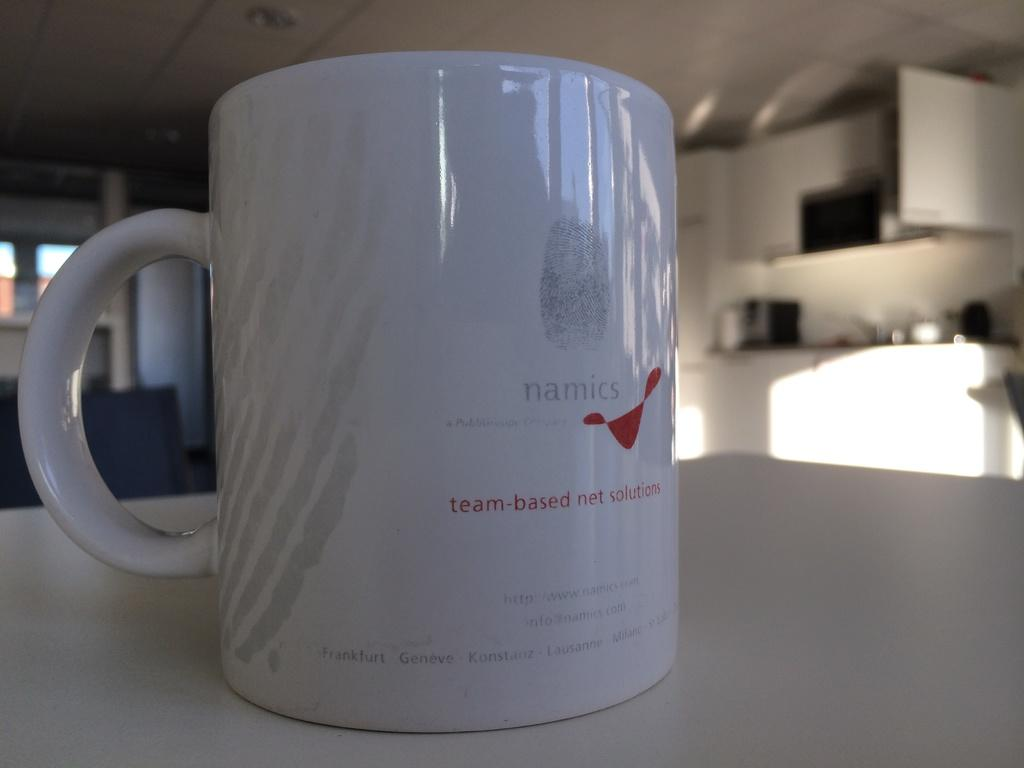<image>
Give a short and clear explanation of the subsequent image. A white mug for Namics net solutions  is wrapped in plastic sitting on a counter top. 